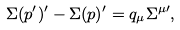<formula> <loc_0><loc_0><loc_500><loc_500>\Sigma ( p ^ { \prime } ) ^ { \prime } - \Sigma ( p ) ^ { \prime } = q _ { \mu } \Sigma ^ { \mu \prime } ,</formula> 